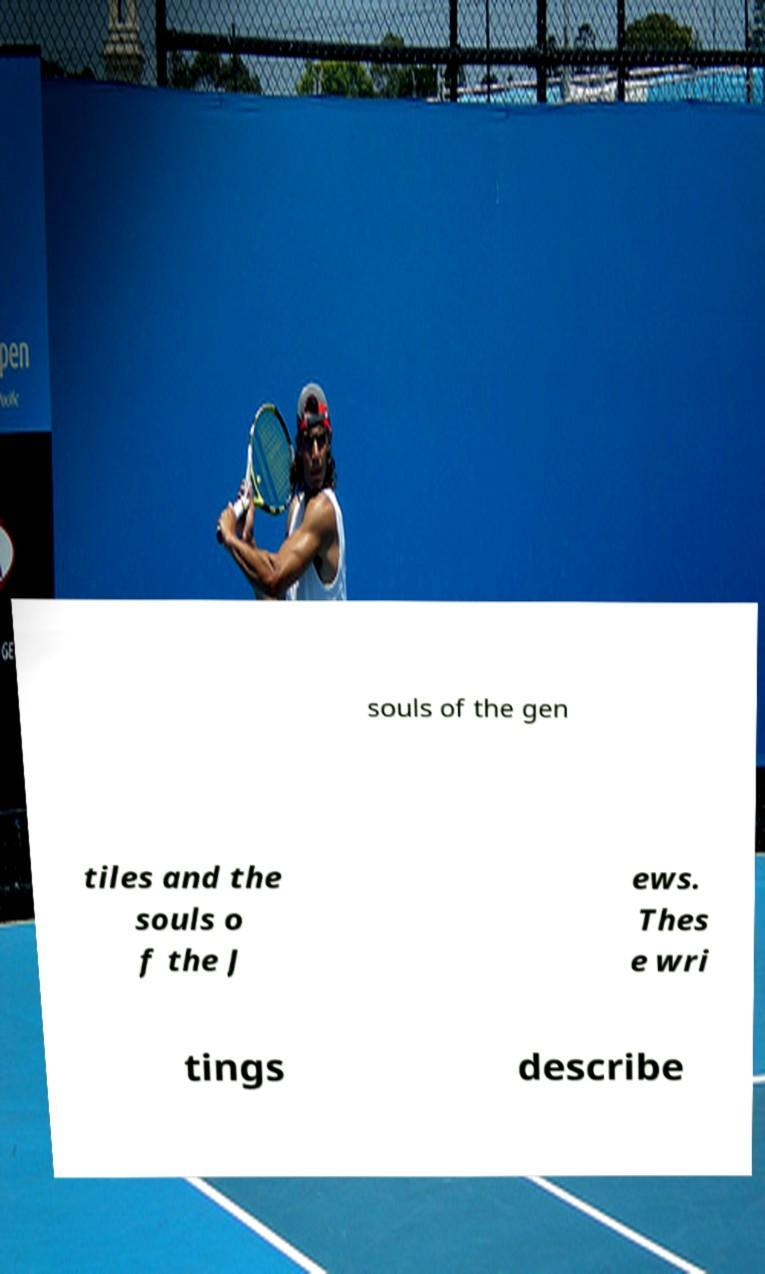Please identify and transcribe the text found in this image. souls of the gen tiles and the souls o f the J ews. Thes e wri tings describe 